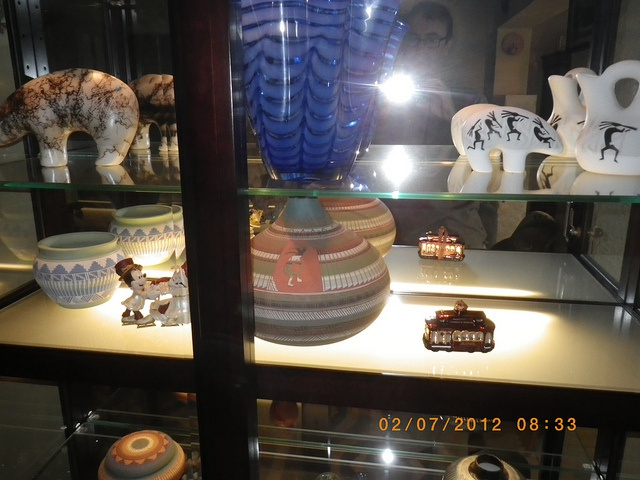Describe the objects in this image and their specific colors. I can see vase in black, gray, navy, and darkblue tones, vase in black, gray, and darkgray tones, bear in black, gray, and maroon tones, people in black, gray, darkgray, and white tones, and vase in black, gray, darkgray, and tan tones in this image. 